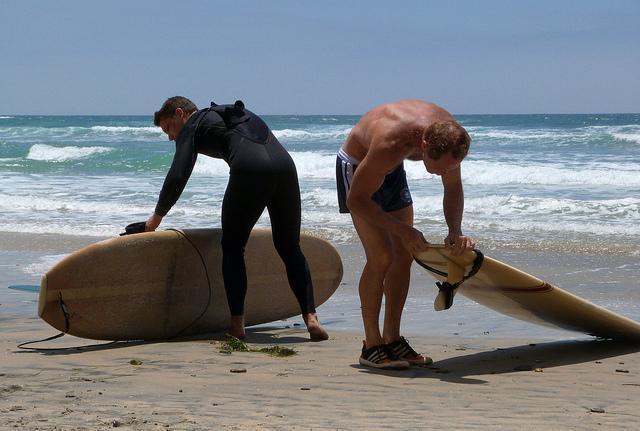How many surfboards?
Give a very brief answer. 2. How many people are in the photo?
Give a very brief answer. 2. How many surfboards are there?
Give a very brief answer. 2. 